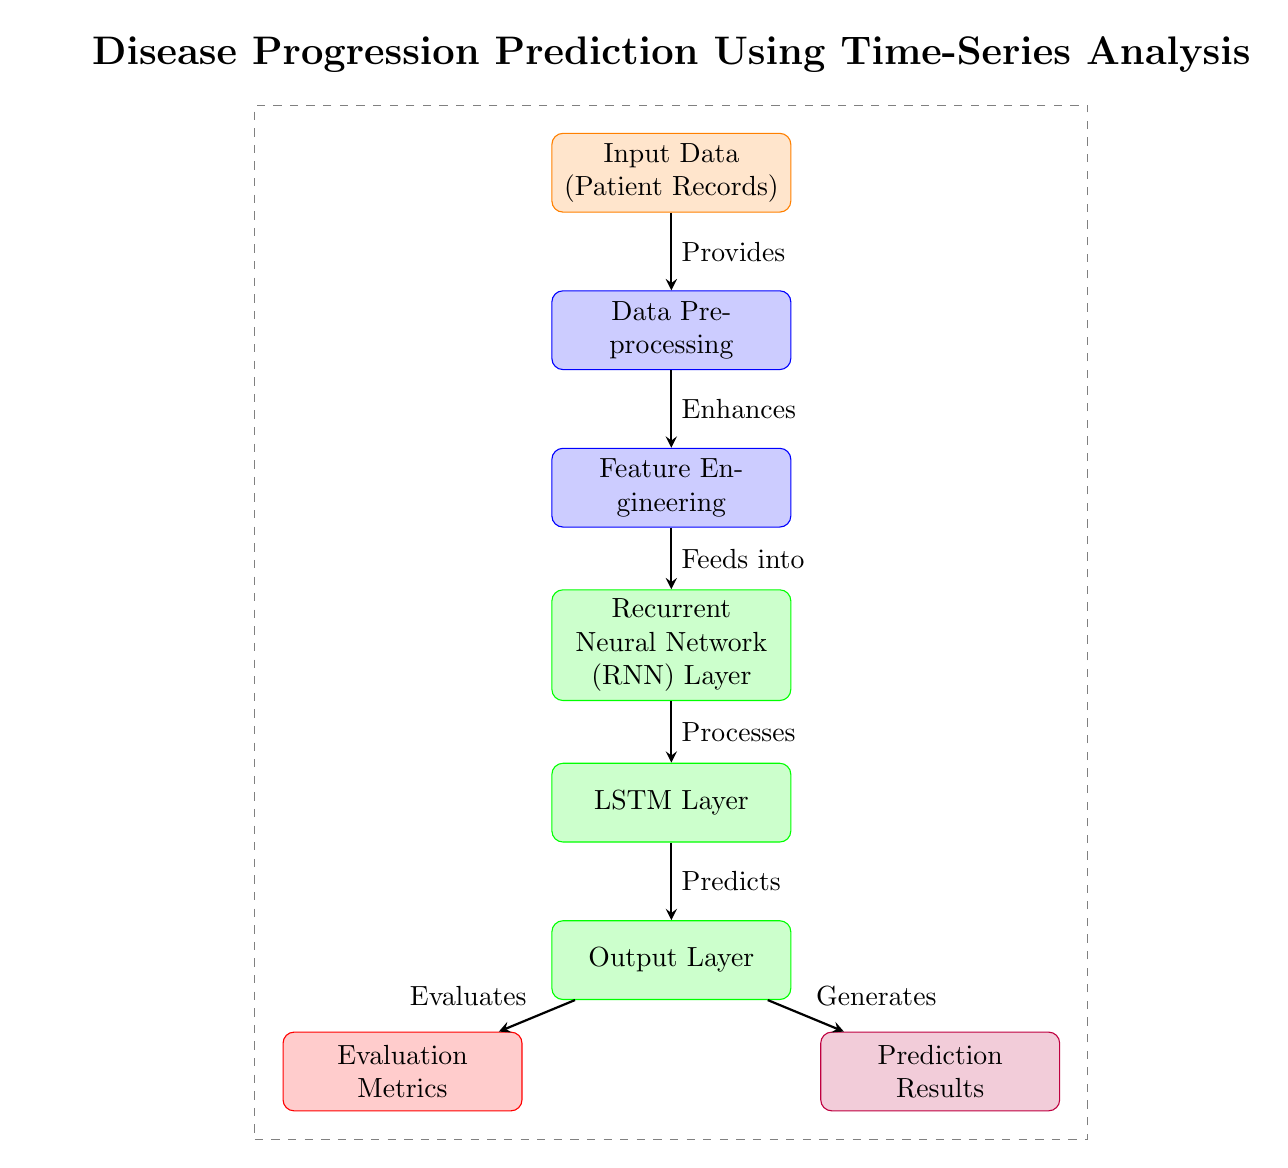What is the first node in the diagram? The first node is labeled "Input Data (Patient Records)", which is positioned at the top of the diagram, representing the input stage of the process.
Answer: Input Data (Patient Records) How many layers are modeled in the diagram? The diagram shows three layers: the RNN Layer, LSTM Layer, and Output Layer, which are located sequentially below the feature engineering component.
Answer: Three layers What is the flow direction of the arrows in the diagram? The arrows connect nodes moving from top to bottom, indicating the flow of data as it processes through various stages.
Answer: Top to bottom What is the purpose of the "Data Preprocessing" node? The "Data Preprocessing" node is essential for enhancing the input data before transforming it into features, making it suitable for the modeling stages that follow.
Answer: Enhances Which node follows the "LSTM Layer"? The node that comes after the "LSTM Layer" is the "Output Layer", making it the final processing stage before predictions are generated.
Answer: Output Layer What does the "Evaluation Metrics" node evaluate? The "Evaluation Metrics" node evaluates the prediction results from the Output Layer to determine the performance of the model.
Answer: Prediction results Explain the relationship between "Feature Engineering" and "Recurrent Neural Network (RNN) Layer". "Feature Engineering" feeds its processed features into the "Recurrent Neural Network (RNN) Layer"; the RNN processes these features to model the sequential data.
Answer: Feeds into How are the predictions generated in the diagram? Predictions are generated by the "Output Layer", which processes inputs from the "LSTM Layer" to present the final prediction results.
Answer: Output Layer What type of model is illustrated at the fourth position in the diagram? The fourth position in the diagram illustrates an "LSTM Layer", which is a type of recurrent neural network model developed to handle sequential data effectively.
Answer: LSTM Layer 